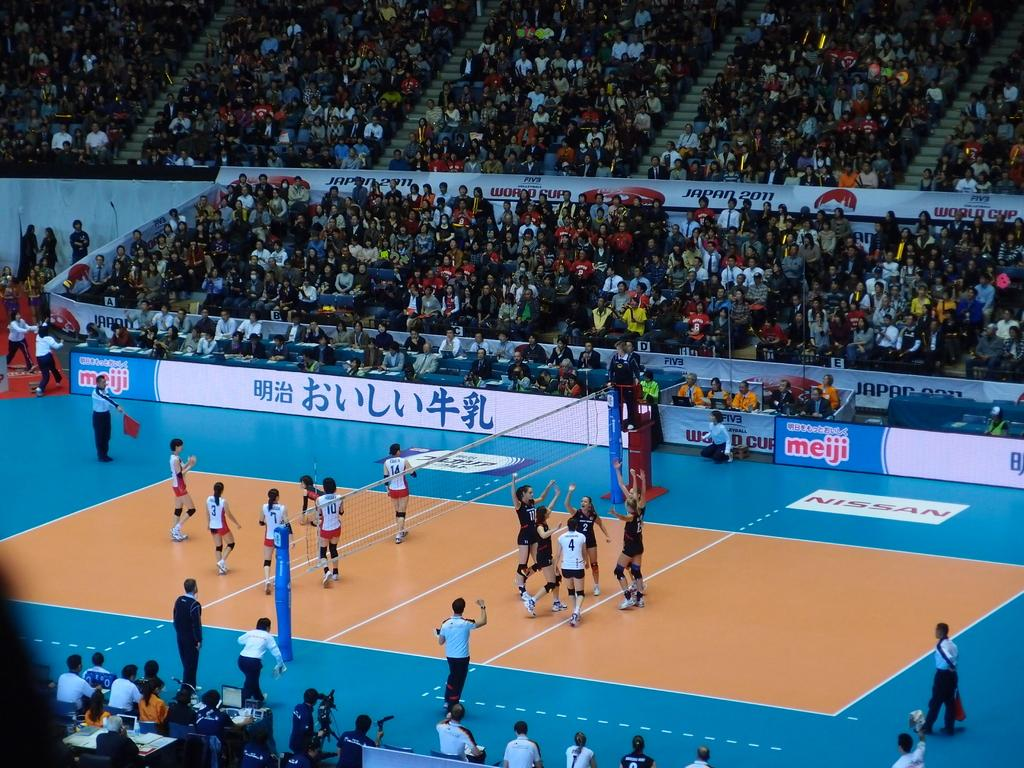<image>
Present a compact description of the photo's key features. A meiji logo can be seen on a basketball court. 